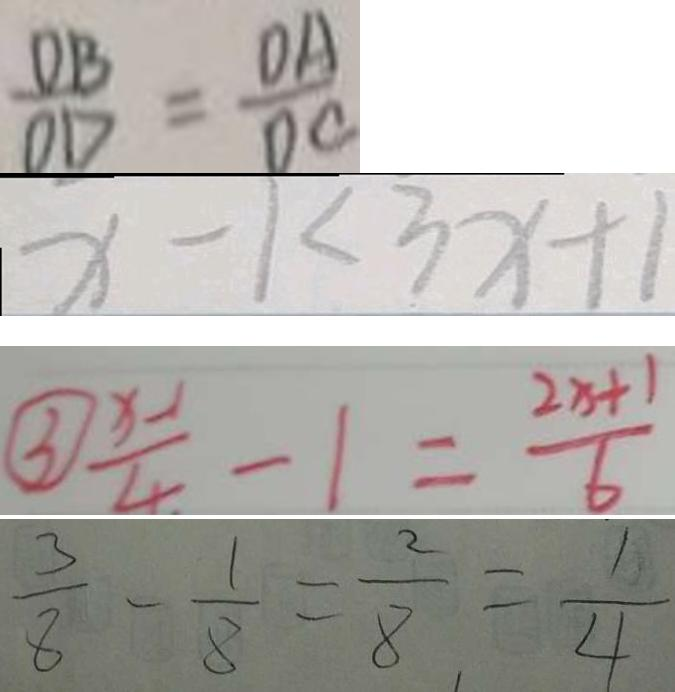<formula> <loc_0><loc_0><loc_500><loc_500>\frac { D B } { O D } = \frac { O A } { D C } 
 x - 1 < 3 x + 1 
 \textcircled { 3 } \frac { x - 1 } { 4 } - 1 = \frac { 2 x + 1 } { 6 } 
 \frac { 3 } { 8 } - \frac { 1 } { 8 } = \frac { 2 } { 8 } = \frac { 1 } { 4 }</formula> 